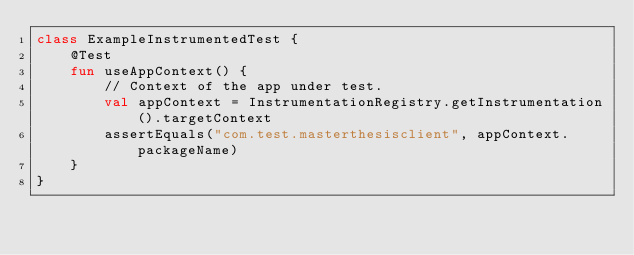Convert code to text. <code><loc_0><loc_0><loc_500><loc_500><_Kotlin_>class ExampleInstrumentedTest {
    @Test
    fun useAppContext() {
        // Context of the app under test.
        val appContext = InstrumentationRegistry.getInstrumentation().targetContext
        assertEquals("com.test.masterthesisclient", appContext.packageName)
    }
}
</code> 